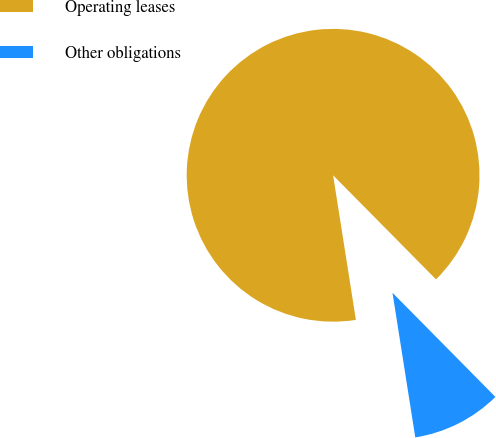Convert chart to OTSL. <chart><loc_0><loc_0><loc_500><loc_500><pie_chart><fcel>Operating leases<fcel>Other obligations<nl><fcel>90.08%<fcel>9.92%<nl></chart> 